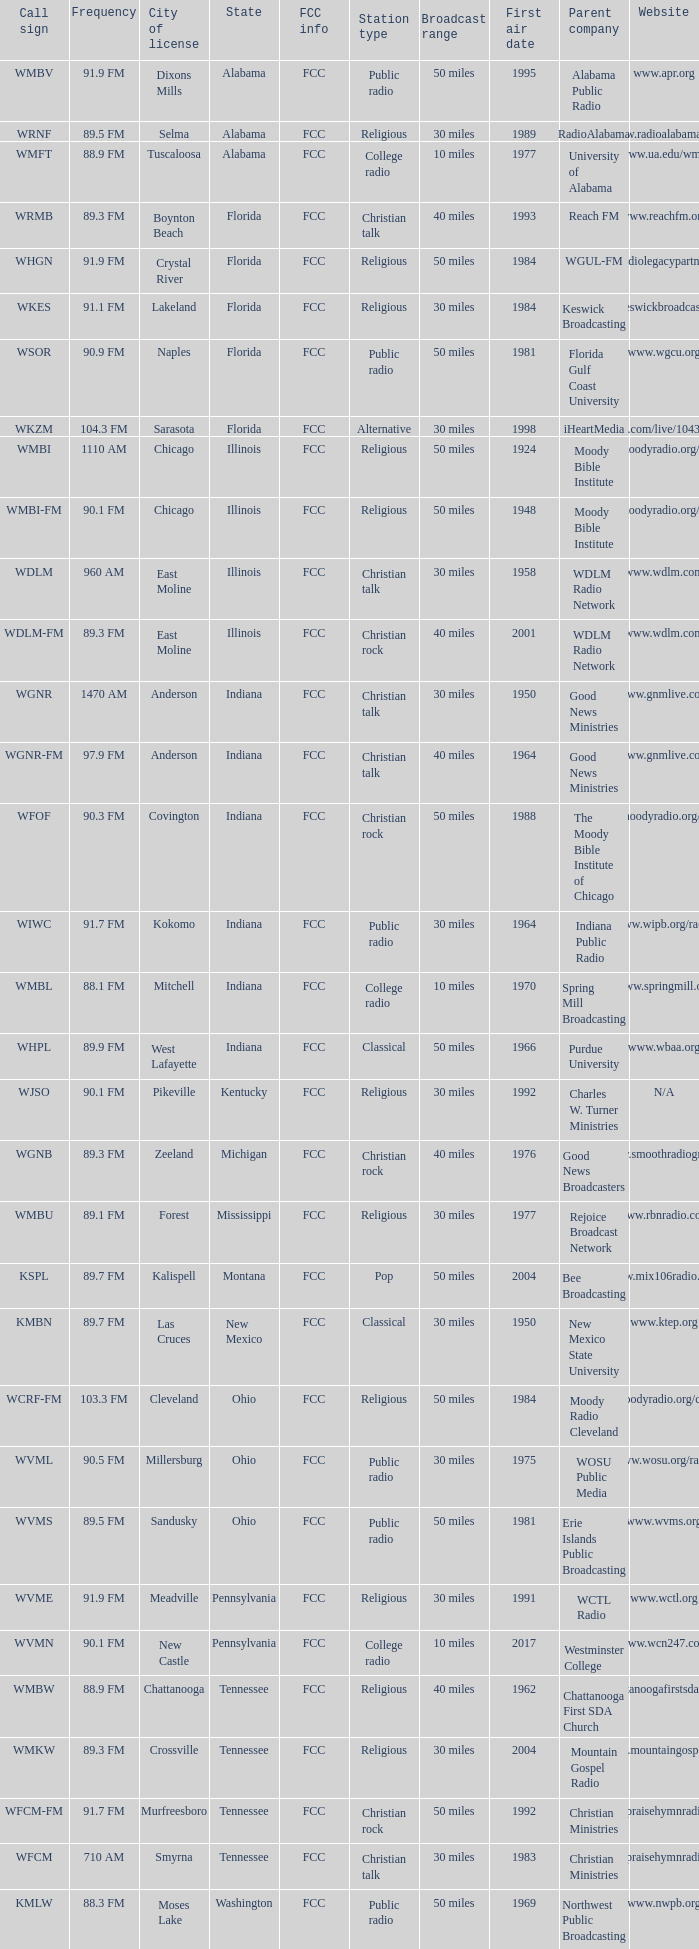What is the periodicity of the radio station in indiana possessing a call sign wgnr? 1470 AM. 